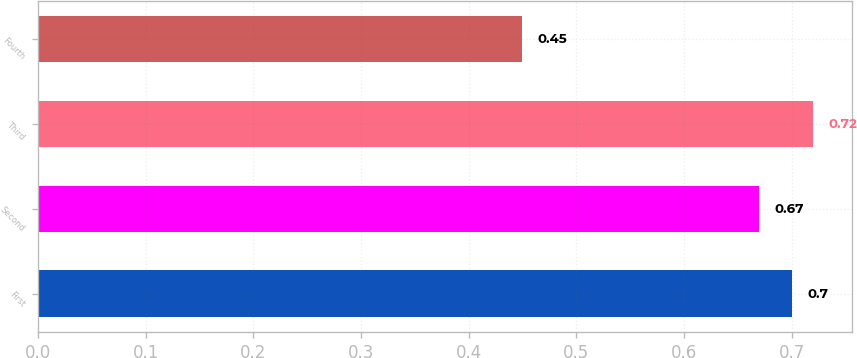<chart> <loc_0><loc_0><loc_500><loc_500><bar_chart><fcel>First<fcel>Second<fcel>Third<fcel>Fourth<nl><fcel>0.7<fcel>0.67<fcel>0.72<fcel>0.45<nl></chart> 